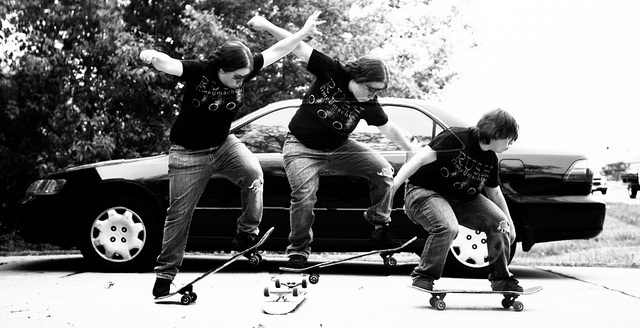Describe the objects in this image and their specific colors. I can see car in gray, black, white, and darkgray tones, people in gray, black, lightgray, and darkgray tones, people in gray, black, darkgray, and lightgray tones, people in gray, black, darkgray, and lightgray tones, and skateboard in gray, black, white, and darkgray tones in this image. 